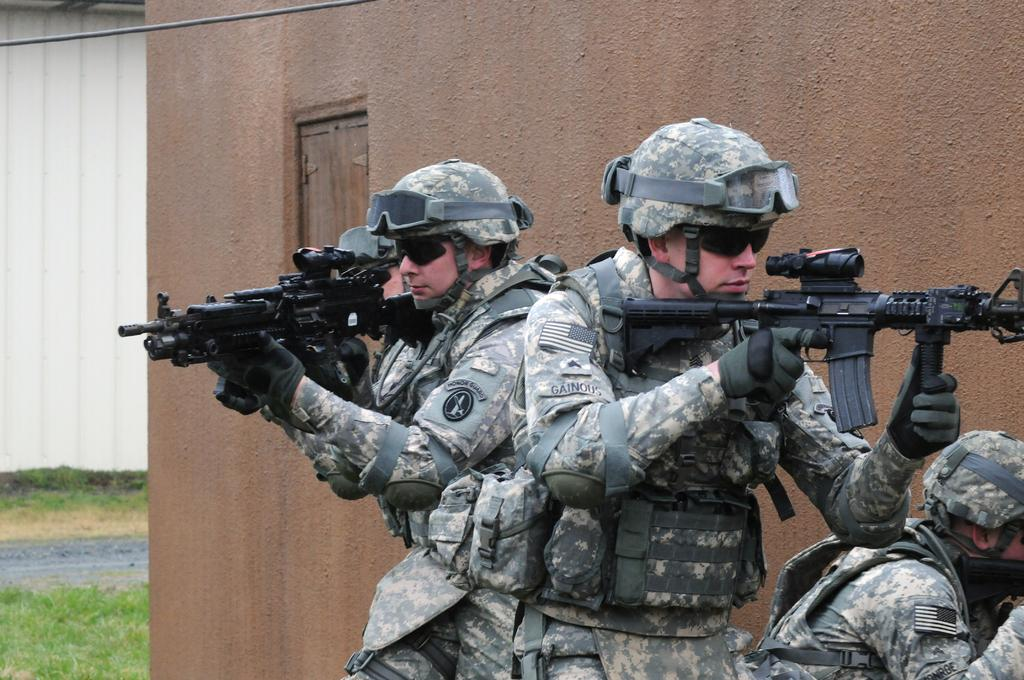How many people are in the image? There is a group of people in the image. What are the people wearing on their heads? The people are wearing helmets. What are the people holding in their hands? The people are holding guns. What can be seen in the background of the image? There are buildings, grass, and a cable in the background of the image. What type of glue is being used by the people in the image? There is no glue present in the image; the people are holding guns. What kind of food can be seen on the table in the image? There is no table or food present in the image. 